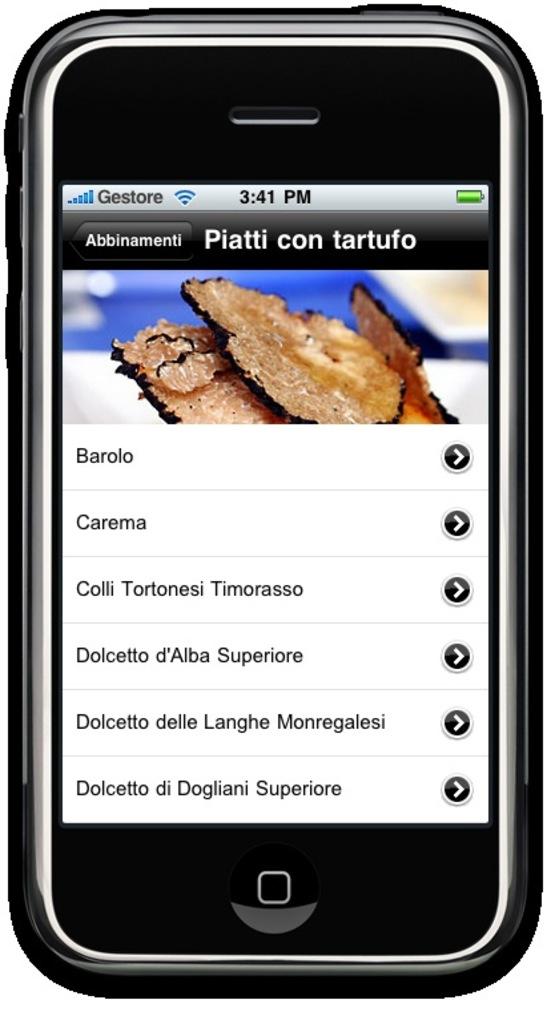What time is it?
Give a very brief answer. 3:41. 